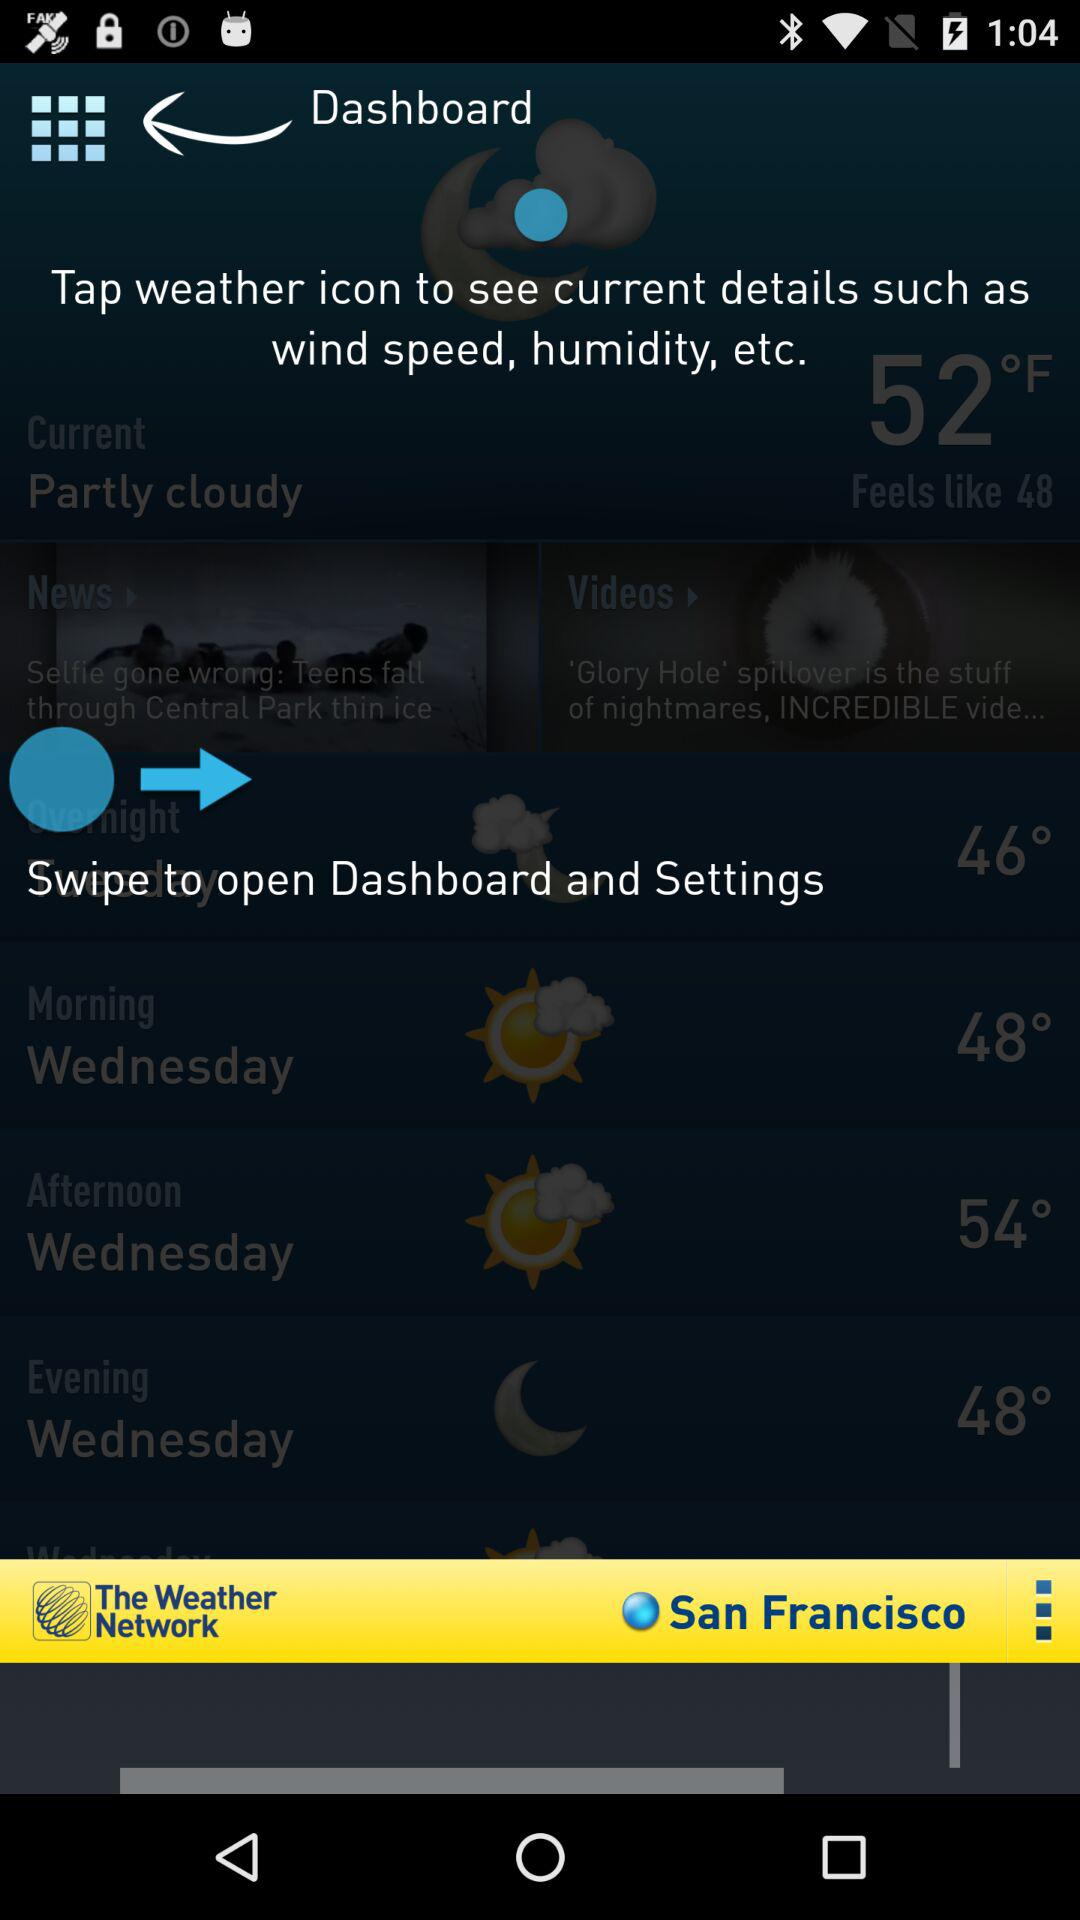What is the app name? The app name is "The Weather Network". 